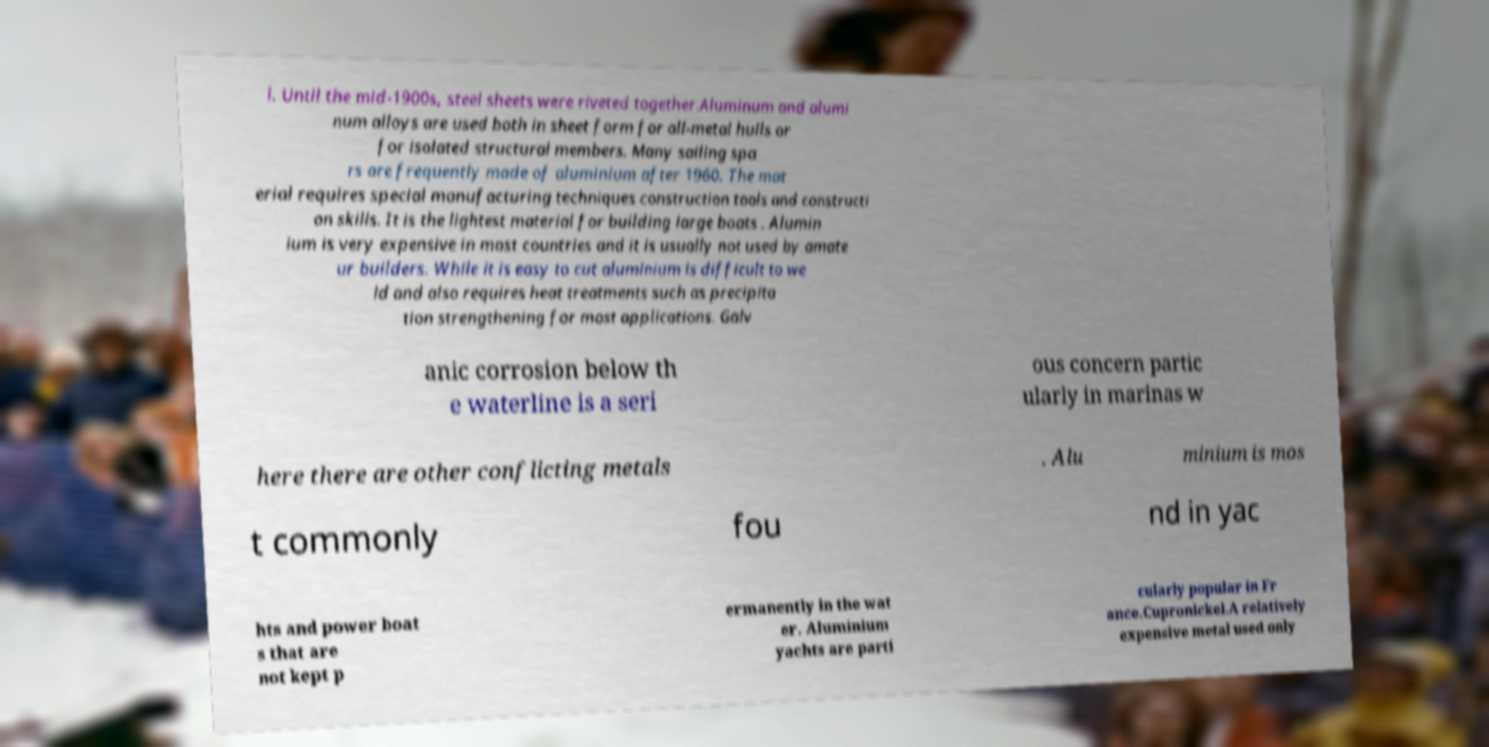Could you extract and type out the text from this image? l. Until the mid-1900s, steel sheets were riveted together.Aluminum and alumi num alloys are used both in sheet form for all-metal hulls or for isolated structural members. Many sailing spa rs are frequently made of aluminium after 1960. The mat erial requires special manufacturing techniques construction tools and constructi on skills. It is the lightest material for building large boats . Alumin ium is very expensive in most countries and it is usually not used by amate ur builders. While it is easy to cut aluminium is difficult to we ld and also requires heat treatments such as precipita tion strengthening for most applications. Galv anic corrosion below th e waterline is a seri ous concern partic ularly in marinas w here there are other conflicting metals . Alu minium is mos t commonly fou nd in yac hts and power boat s that are not kept p ermanently in the wat er. Aluminium yachts are parti cularly popular in Fr ance.Cupronickel.A relatively expensive metal used only 